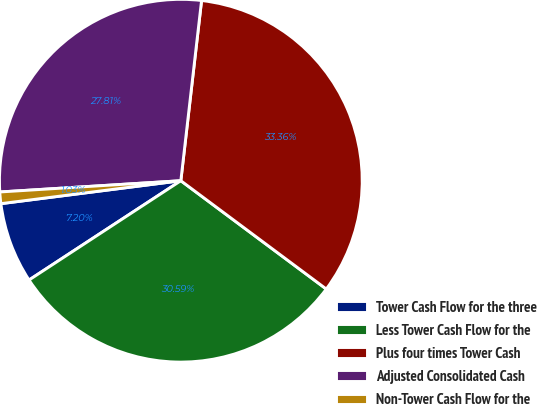<chart> <loc_0><loc_0><loc_500><loc_500><pie_chart><fcel>Tower Cash Flow for the three<fcel>Less Tower Cash Flow for the<fcel>Plus four times Tower Cash<fcel>Adjusted Consolidated Cash<fcel>Non-Tower Cash Flow for the<nl><fcel>7.2%<fcel>30.59%<fcel>33.36%<fcel>27.81%<fcel>1.03%<nl></chart> 